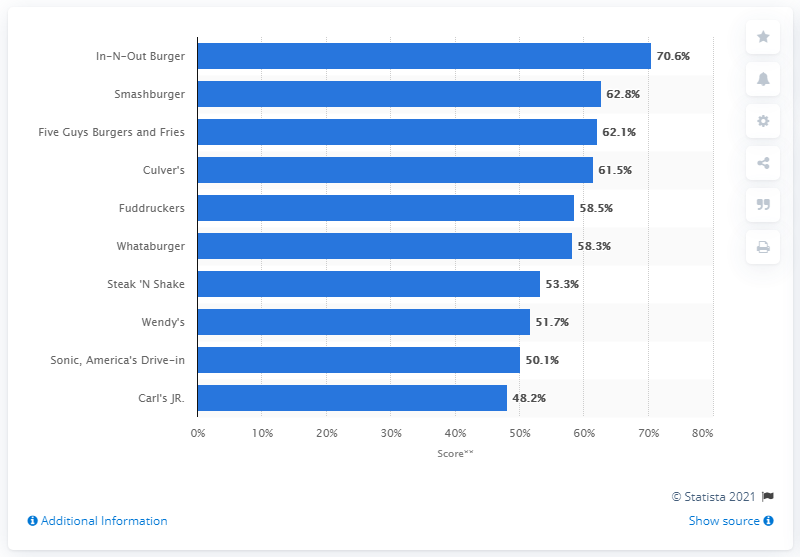Give some essential details in this illustration. Fuddruckers, a limited-service hamburger restaurant, ranked fifth in the hamburger segment. 